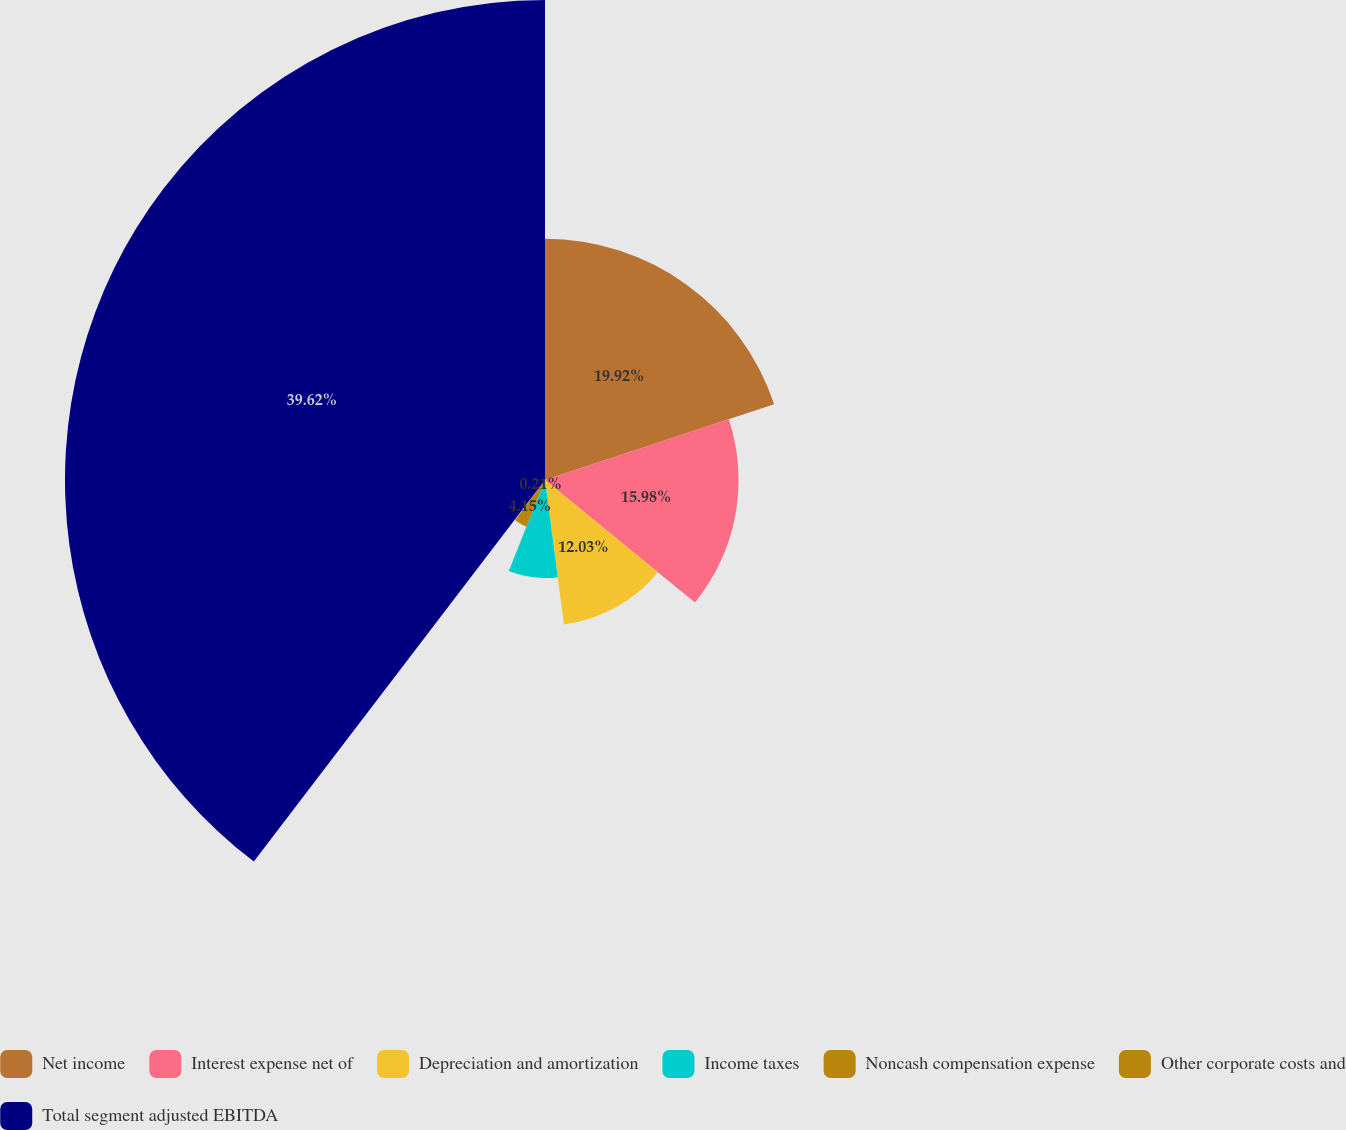Convert chart to OTSL. <chart><loc_0><loc_0><loc_500><loc_500><pie_chart><fcel>Net income<fcel>Interest expense net of<fcel>Depreciation and amortization<fcel>Income taxes<fcel>Noncash compensation expense<fcel>Other corporate costs and<fcel>Total segment adjusted EBITDA<nl><fcel>19.92%<fcel>15.98%<fcel>12.03%<fcel>8.09%<fcel>4.15%<fcel>0.21%<fcel>39.63%<nl></chart> 